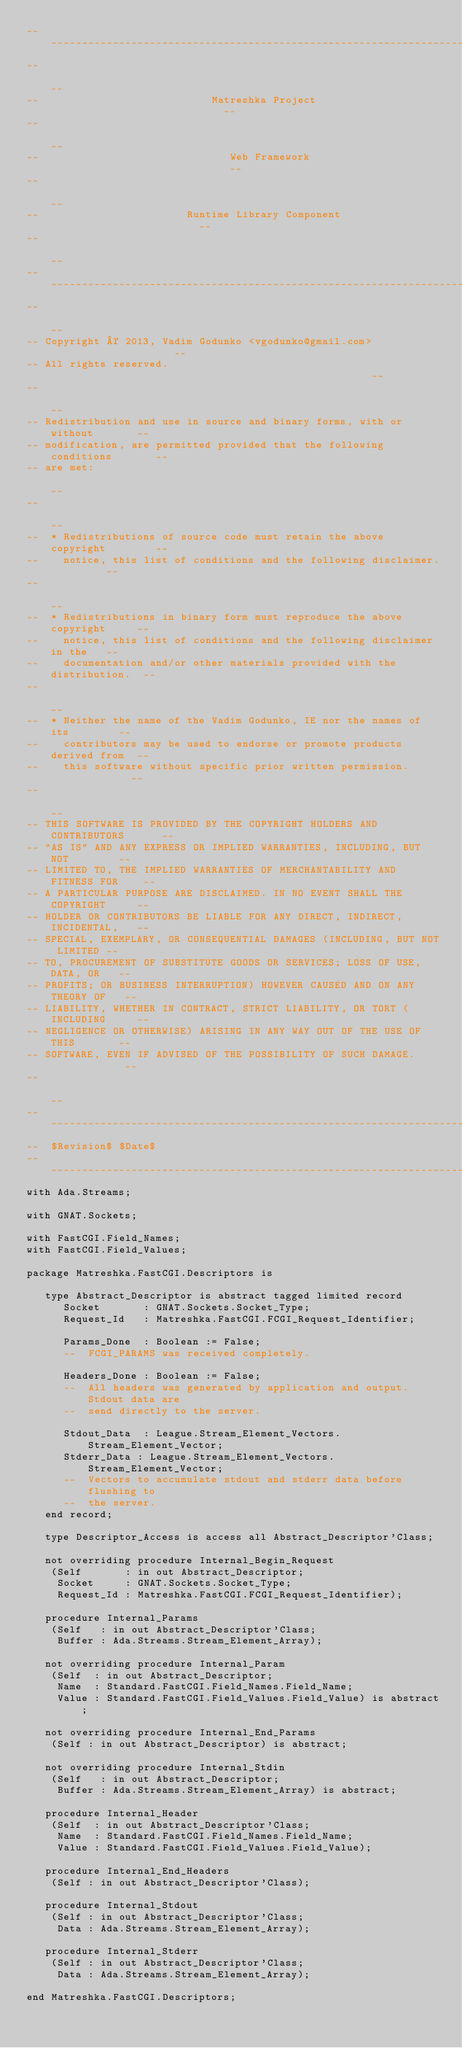Convert code to text. <code><loc_0><loc_0><loc_500><loc_500><_Ada_>------------------------------------------------------------------------------
--                                                                          --
--                            Matreshka Project                             --
--                                                                          --
--                               Web Framework                              --
--                                                                          --
--                        Runtime Library Component                         --
--                                                                          --
------------------------------------------------------------------------------
--                                                                          --
-- Copyright © 2013, Vadim Godunko <vgodunko@gmail.com>                     --
-- All rights reserved.                                                     --
--                                                                          --
-- Redistribution and use in source and binary forms, with or without       --
-- modification, are permitted provided that the following conditions       --
-- are met:                                                                 --
--                                                                          --
--  * Redistributions of source code must retain the above copyright        --
--    notice, this list of conditions and the following disclaimer.         --
--                                                                          --
--  * Redistributions in binary form must reproduce the above copyright     --
--    notice, this list of conditions and the following disclaimer in the   --
--    documentation and/or other materials provided with the distribution.  --
--                                                                          --
--  * Neither the name of the Vadim Godunko, IE nor the names of its        --
--    contributors may be used to endorse or promote products derived from  --
--    this software without specific prior written permission.              --
--                                                                          --
-- THIS SOFTWARE IS PROVIDED BY THE COPYRIGHT HOLDERS AND CONTRIBUTORS      --
-- "AS IS" AND ANY EXPRESS OR IMPLIED WARRANTIES, INCLUDING, BUT NOT        --
-- LIMITED TO, THE IMPLIED WARRANTIES OF MERCHANTABILITY AND FITNESS FOR    --
-- A PARTICULAR PURPOSE ARE DISCLAIMED. IN NO EVENT SHALL THE COPYRIGHT     --
-- HOLDER OR CONTRIBUTORS BE LIABLE FOR ANY DIRECT, INDIRECT, INCIDENTAL,   --
-- SPECIAL, EXEMPLARY, OR CONSEQUENTIAL DAMAGES (INCLUDING, BUT NOT LIMITED --
-- TO, PROCUREMENT OF SUBSTITUTE GOODS OR SERVICES; LOSS OF USE, DATA, OR   --
-- PROFITS; OR BUSINESS INTERRUPTION) HOWEVER CAUSED AND ON ANY THEORY OF   --
-- LIABILITY, WHETHER IN CONTRACT, STRICT LIABILITY, OR TORT (INCLUDING     --
-- NEGLIGENCE OR OTHERWISE) ARISING IN ANY WAY OUT OF THE USE OF THIS       --
-- SOFTWARE, EVEN IF ADVISED OF THE POSSIBILITY OF SUCH DAMAGE.             --
--                                                                          --
------------------------------------------------------------------------------
--  $Revision$ $Date$
------------------------------------------------------------------------------
with Ada.Streams;

with GNAT.Sockets;

with FastCGI.Field_Names;
with FastCGI.Field_Values;

package Matreshka.FastCGI.Descriptors is

   type Abstract_Descriptor is abstract tagged limited record
      Socket       : GNAT.Sockets.Socket_Type;
      Request_Id   : Matreshka.FastCGI.FCGI_Request_Identifier;

      Params_Done  : Boolean := False;
      --  FCGI_PARAMS was received completely.

      Headers_Done : Boolean := False;
      --  All headers was generated by application and output. Stdout data are
      --  send directly to the server.

      Stdout_Data  : League.Stream_Element_Vectors.Stream_Element_Vector;
      Stderr_Data : League.Stream_Element_Vectors.Stream_Element_Vector;
      --  Vectors to accumulate stdout and stderr data before flushing to
      --  the server.
   end record;

   type Descriptor_Access is access all Abstract_Descriptor'Class;

   not overriding procedure Internal_Begin_Request
    (Self       : in out Abstract_Descriptor;
     Socket     : GNAT.Sockets.Socket_Type;
     Request_Id : Matreshka.FastCGI.FCGI_Request_Identifier);

   procedure Internal_Params
    (Self   : in out Abstract_Descriptor'Class;
     Buffer : Ada.Streams.Stream_Element_Array);

   not overriding procedure Internal_Param
    (Self  : in out Abstract_Descriptor;
     Name  : Standard.FastCGI.Field_Names.Field_Name;
     Value : Standard.FastCGI.Field_Values.Field_Value) is abstract;

   not overriding procedure Internal_End_Params
    (Self : in out Abstract_Descriptor) is abstract;

   not overriding procedure Internal_Stdin
    (Self   : in out Abstract_Descriptor;
     Buffer : Ada.Streams.Stream_Element_Array) is abstract;

   procedure Internal_Header
    (Self  : in out Abstract_Descriptor'Class;
     Name  : Standard.FastCGI.Field_Names.Field_Name;
     Value : Standard.FastCGI.Field_Values.Field_Value);

   procedure Internal_End_Headers
    (Self : in out Abstract_Descriptor'Class);

   procedure Internal_Stdout
    (Self : in out Abstract_Descriptor'Class;
     Data : Ada.Streams.Stream_Element_Array);

   procedure Internal_Stderr
    (Self : in out Abstract_Descriptor'Class;
     Data : Ada.Streams.Stream_Element_Array);

end Matreshka.FastCGI.Descriptors;
</code> 